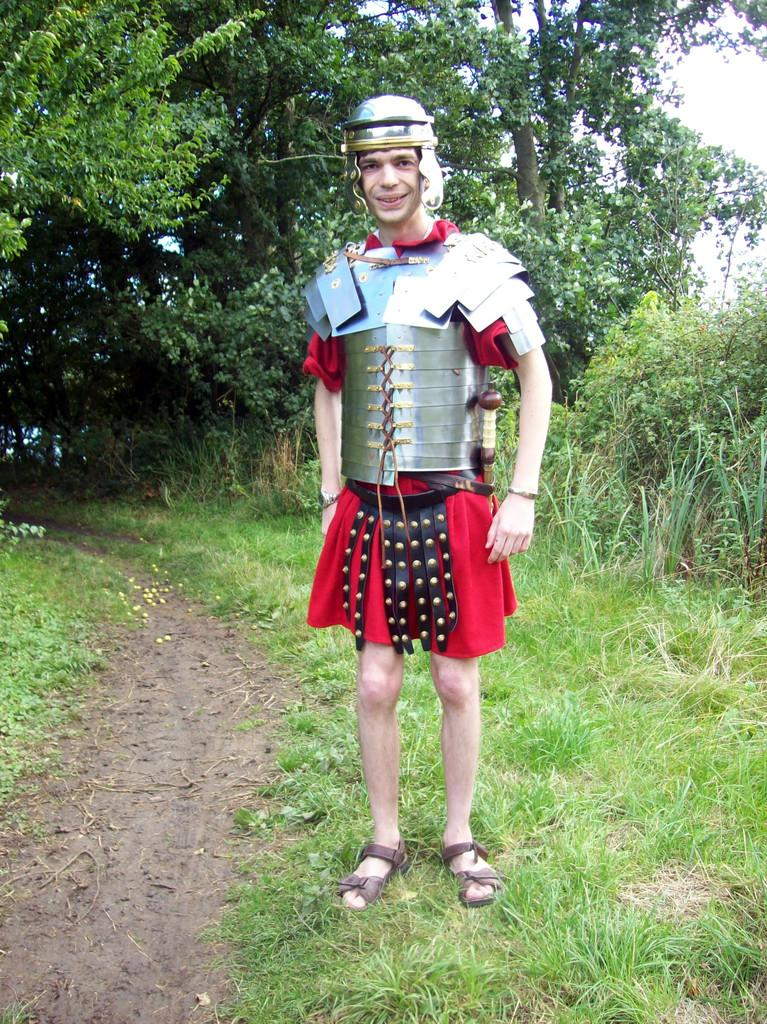Who is the main subject in the foreground of the image? There is a man in the foreground of the image. What is the man wearing? The man is wearing a warrior dress. What is the man standing on? The man is standing on the grass. What can be seen in the background of the image? There are many trees visible in the background of the image. What type of suit is the man wearing in the image? The man is not wearing a suit; he is wearing a warrior dress. Can you see the man's heart beating in the image? There is no indication of the man's heart in the image. 